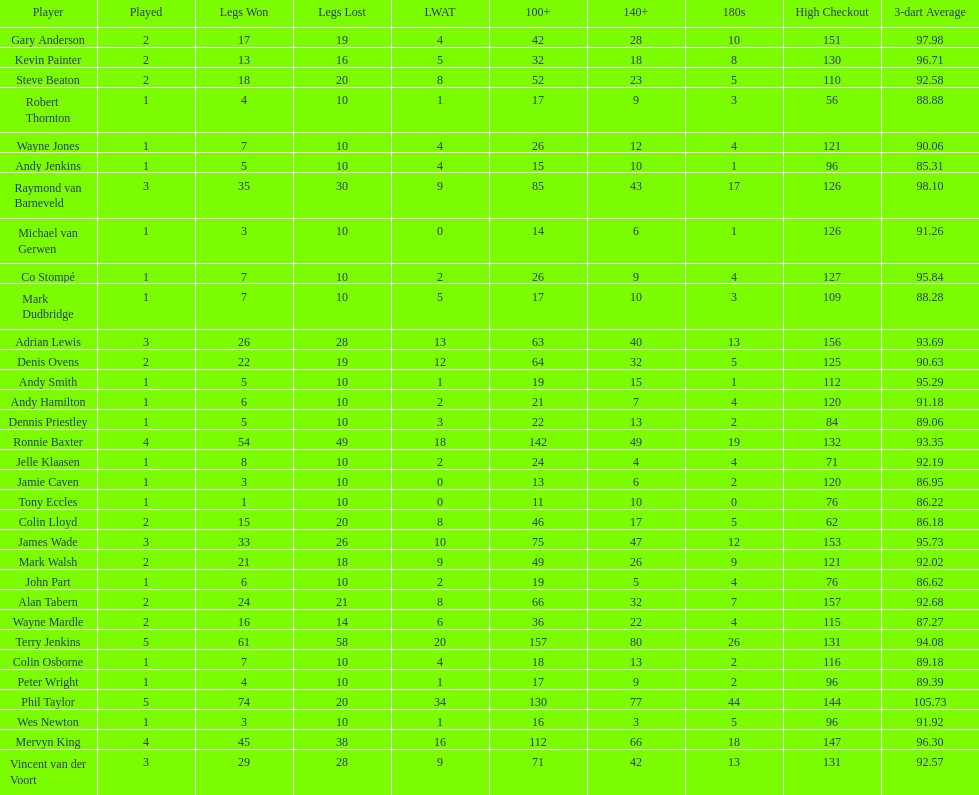What is the total amount of players who played more than 3 games? 4. 